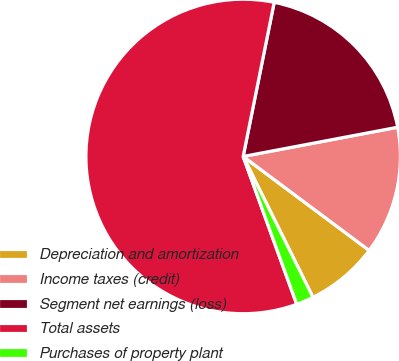<chart> <loc_0><loc_0><loc_500><loc_500><pie_chart><fcel>Depreciation and amortization<fcel>Income taxes (credit)<fcel>Segment net earnings (loss)<fcel>Total assets<fcel>Purchases of property plant<nl><fcel>7.48%<fcel>13.17%<fcel>18.86%<fcel>58.69%<fcel>1.79%<nl></chart> 